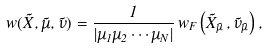Convert formula to latex. <formula><loc_0><loc_0><loc_500><loc_500>w ( \vec { X } , \vec { \mu } , \vec { \nu } ) = \frac { 1 } { | \mu _ { 1 } \mu _ { 2 } \cdots \mu _ { N } | } \, w _ { F } \left ( \vec { X } _ { \vec { \mu } } \, , \vec { \nu } _ { \vec { \mu } } \right ) ,</formula> 